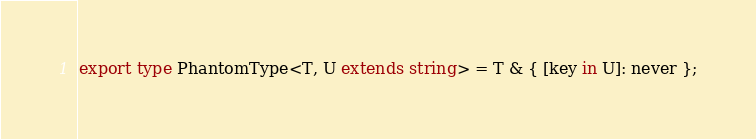<code> <loc_0><loc_0><loc_500><loc_500><_TypeScript_>export type PhantomType<T, U extends string> = T & { [key in U]: never };
</code> 